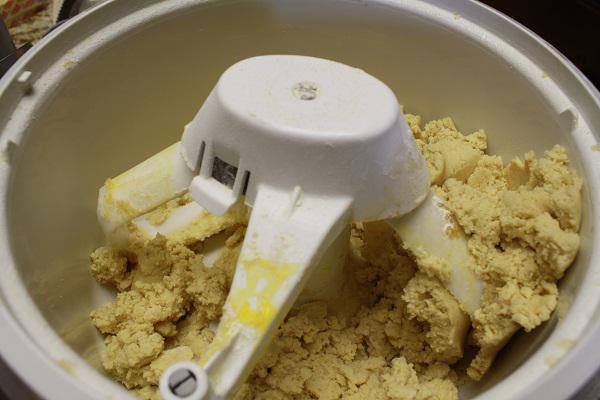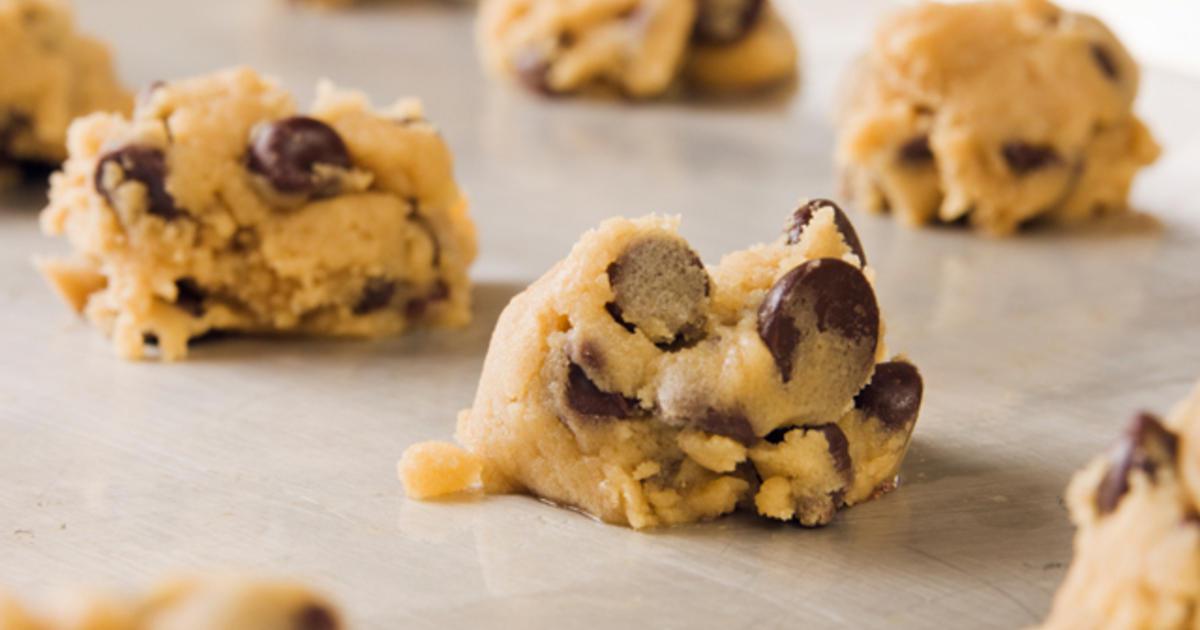The first image is the image on the left, the second image is the image on the right. Considering the images on both sides, is "The right image features mounds of raw cookie dough in rows with a metal sheet under them." valid? Answer yes or no. Yes. The first image is the image on the left, the second image is the image on the right. For the images displayed, is the sentence "There are multiple raw cookies on a baking sheet." factually correct? Answer yes or no. Yes. 